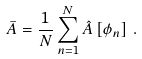Convert formula to latex. <formula><loc_0><loc_0><loc_500><loc_500>\bar { A } = \frac { 1 } { N } \sum _ { n = 1 } ^ { N } \hat { A } \left [ \phi _ { n } \right ] \, .</formula> 